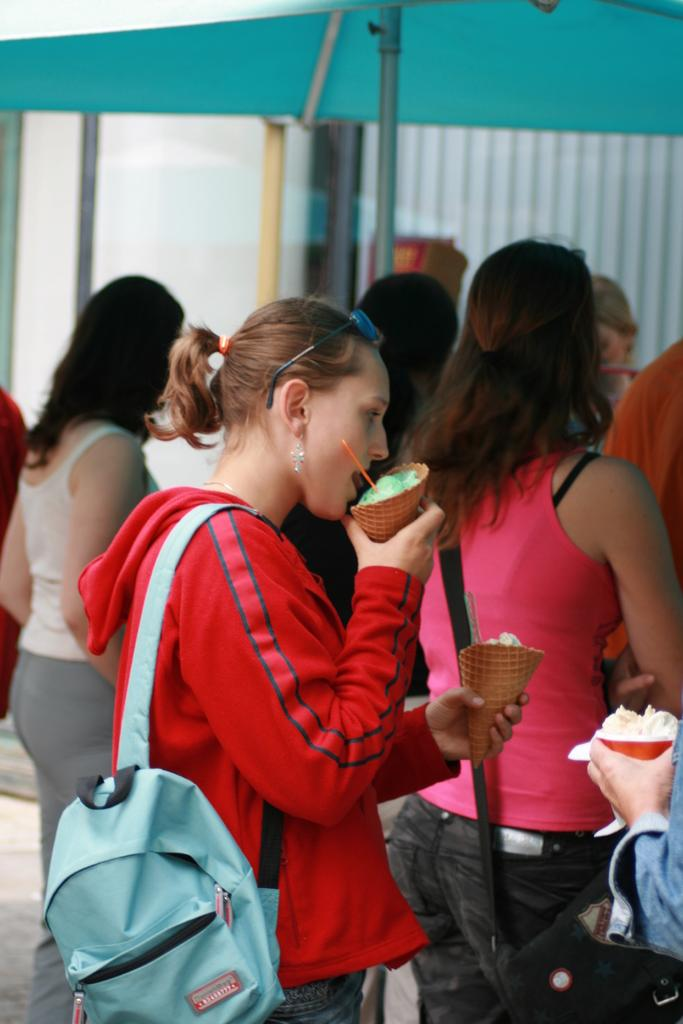What is the woman in the image wearing? The woman is wearing a red dress in the image. What is the woman holding in her hands? The woman is holding ice creams in both hands. Can you describe the group of people near the woman? There is a group of ladies beside the woman in the image. What type of wood can be seen in the chin of the woman in the image? There is no wood or chin visible in the image; it features a woman wearing a red dress and holding ice creams. 